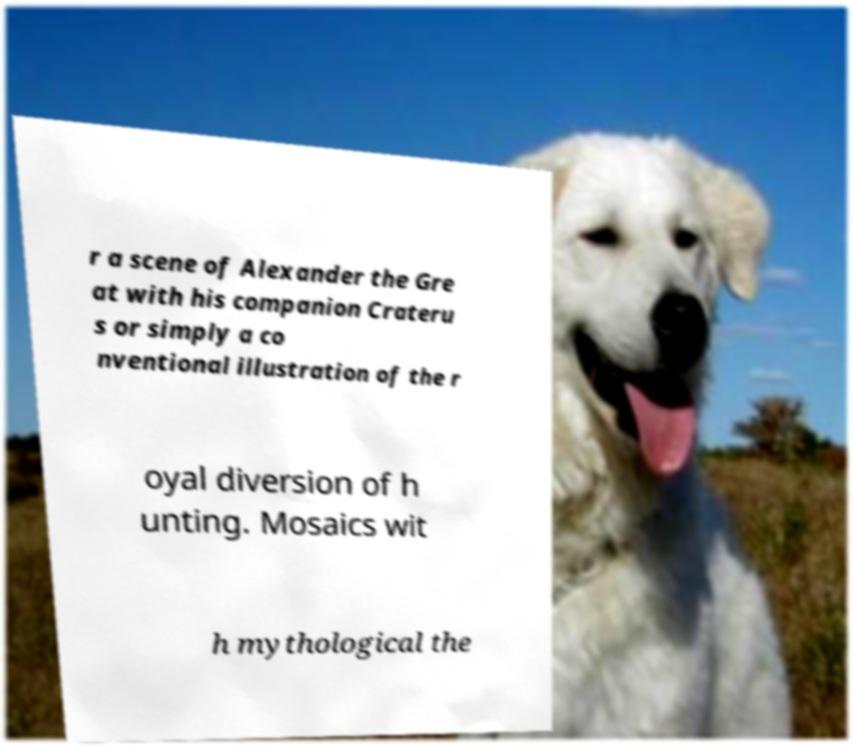Could you extract and type out the text from this image? r a scene of Alexander the Gre at with his companion Crateru s or simply a co nventional illustration of the r oyal diversion of h unting. Mosaics wit h mythological the 